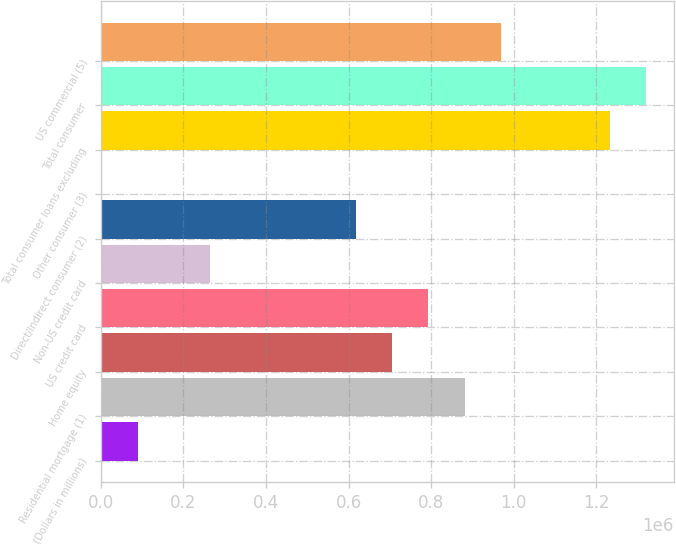Convert chart to OTSL. <chart><loc_0><loc_0><loc_500><loc_500><bar_chart><fcel>(Dollars in millions)<fcel>Residential mortgage (1)<fcel>Home equity<fcel>US credit card<fcel>Non-US credit card<fcel>Direct/Indirect consumer (2)<fcel>Other consumer (3)<fcel>Total consumer loans excluding<fcel>Total consumer<fcel>US commercial (5)<nl><fcel>89800.5<fcel>881391<fcel>705482<fcel>793436<fcel>265710<fcel>617528<fcel>1846<fcel>1.23321e+06<fcel>1.32116e+06<fcel>969346<nl></chart> 